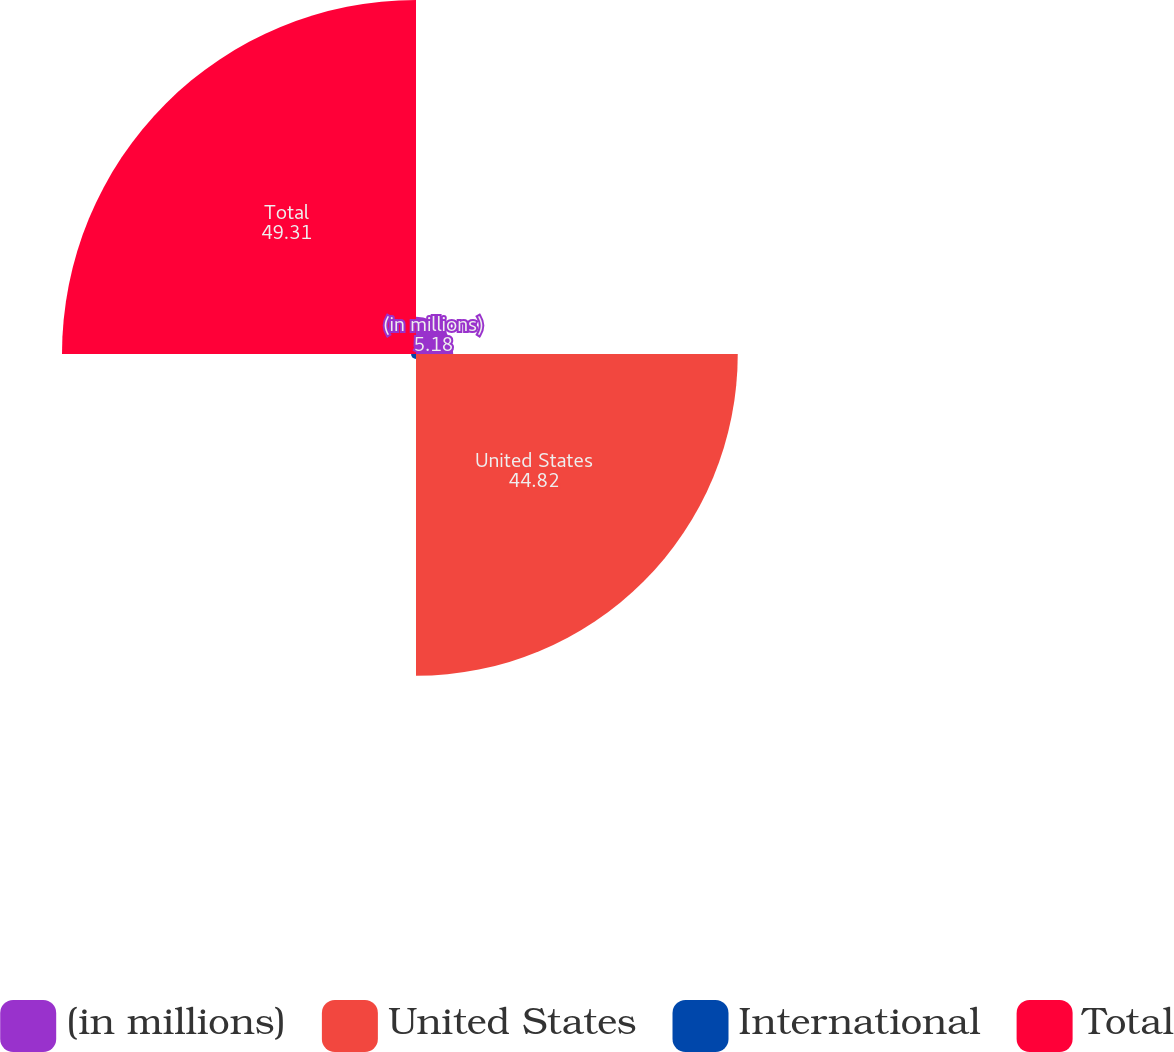<chart> <loc_0><loc_0><loc_500><loc_500><pie_chart><fcel>(in millions)<fcel>United States<fcel>International<fcel>Total<nl><fcel>5.18%<fcel>44.82%<fcel>0.69%<fcel>49.31%<nl></chart> 